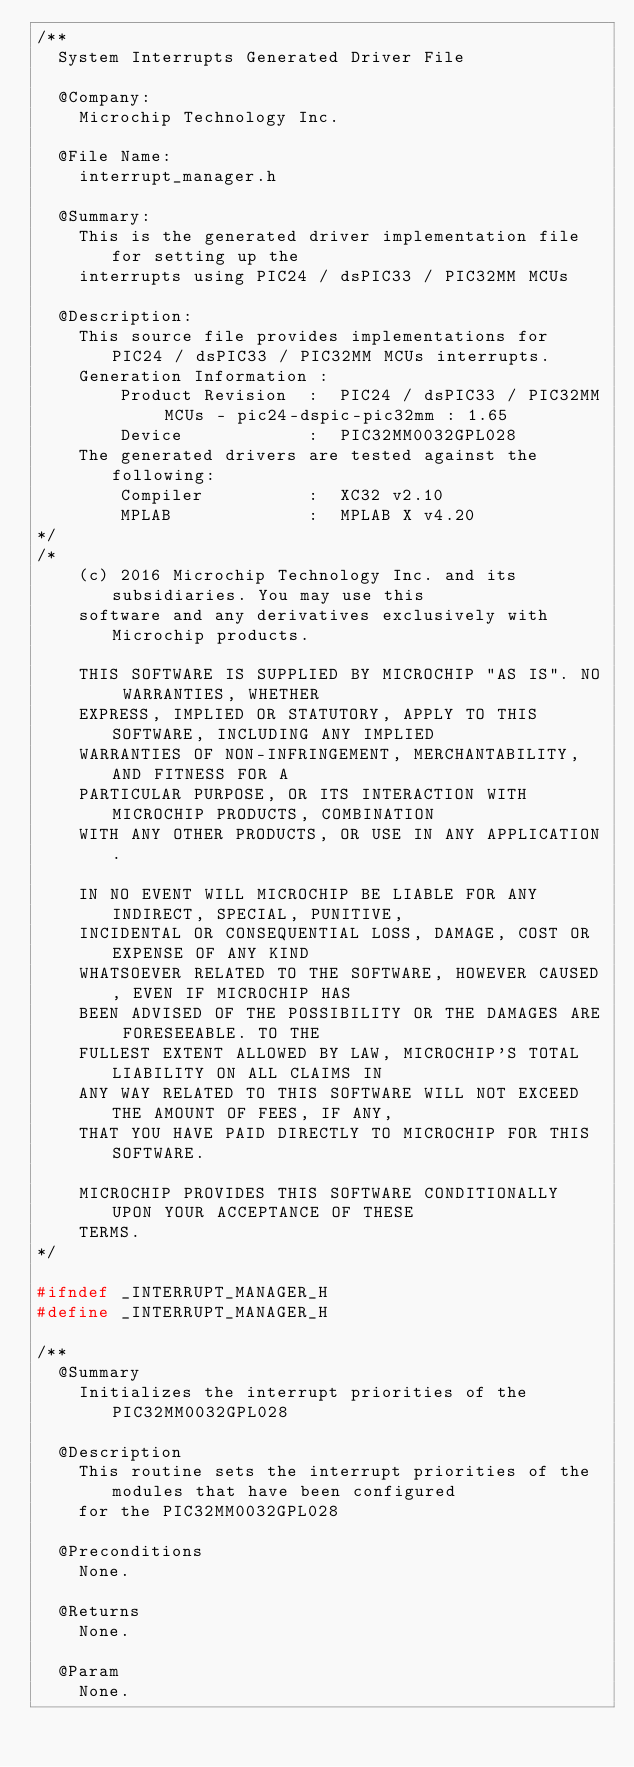<code> <loc_0><loc_0><loc_500><loc_500><_C_>/**
  System Interrupts Generated Driver File 

  @Company:
    Microchip Technology Inc.

  @File Name:
    interrupt_manager.h

  @Summary:
    This is the generated driver implementation file for setting up the
    interrupts using PIC24 / dsPIC33 / PIC32MM MCUs

  @Description:
    This source file provides implementations for PIC24 / dsPIC33 / PIC32MM MCUs interrupts.
    Generation Information : 
        Product Revision  :  PIC24 / dsPIC33 / PIC32MM MCUs - pic24-dspic-pic32mm : 1.65
        Device            :  PIC32MM0032GPL028
    The generated drivers are tested against the following:
        Compiler          :  XC32 v2.10
        MPLAB             :  MPLAB X v4.20
*/
/*
    (c) 2016 Microchip Technology Inc. and its subsidiaries. You may use this
    software and any derivatives exclusively with Microchip products.

    THIS SOFTWARE IS SUPPLIED BY MICROCHIP "AS IS". NO WARRANTIES, WHETHER
    EXPRESS, IMPLIED OR STATUTORY, APPLY TO THIS SOFTWARE, INCLUDING ANY IMPLIED
    WARRANTIES OF NON-INFRINGEMENT, MERCHANTABILITY, AND FITNESS FOR A
    PARTICULAR PURPOSE, OR ITS INTERACTION WITH MICROCHIP PRODUCTS, COMBINATION
    WITH ANY OTHER PRODUCTS, OR USE IN ANY APPLICATION.

    IN NO EVENT WILL MICROCHIP BE LIABLE FOR ANY INDIRECT, SPECIAL, PUNITIVE,
    INCIDENTAL OR CONSEQUENTIAL LOSS, DAMAGE, COST OR EXPENSE OF ANY KIND
    WHATSOEVER RELATED TO THE SOFTWARE, HOWEVER CAUSED, EVEN IF MICROCHIP HAS
    BEEN ADVISED OF THE POSSIBILITY OR THE DAMAGES ARE FORESEEABLE. TO THE
    FULLEST EXTENT ALLOWED BY LAW, MICROCHIP'S TOTAL LIABILITY ON ALL CLAIMS IN
    ANY WAY RELATED TO THIS SOFTWARE WILL NOT EXCEED THE AMOUNT OF FEES, IF ANY,
    THAT YOU HAVE PAID DIRECTLY TO MICROCHIP FOR THIS SOFTWARE.

    MICROCHIP PROVIDES THIS SOFTWARE CONDITIONALLY UPON YOUR ACCEPTANCE OF THESE
    TERMS.
*/

#ifndef _INTERRUPT_MANAGER_H
#define _INTERRUPT_MANAGER_H

/**
  @Summary
    Initializes the interrupt priorities of the PIC32MM0032GPL028

  @Description
    This routine sets the interrupt priorities of the modules that have been configured
    for the PIC32MM0032GPL028

  @Preconditions
    None.

  @Returns
    None.

  @Param
    None.
</code> 